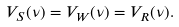Convert formula to latex. <formula><loc_0><loc_0><loc_500><loc_500>V _ { S } ( \nu ) = V _ { W } ( \nu ) = V _ { R } ( \nu ) .</formula> 